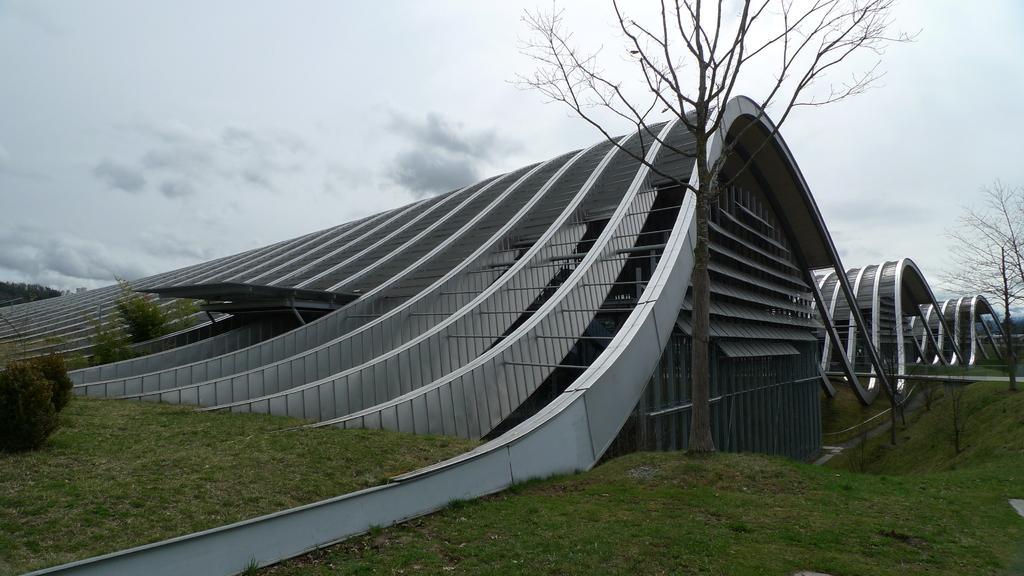Can you describe this image briefly? In this image in the center there is a museum, at the bottom there is grass and also there are trees and plants. At the top there is sky. 